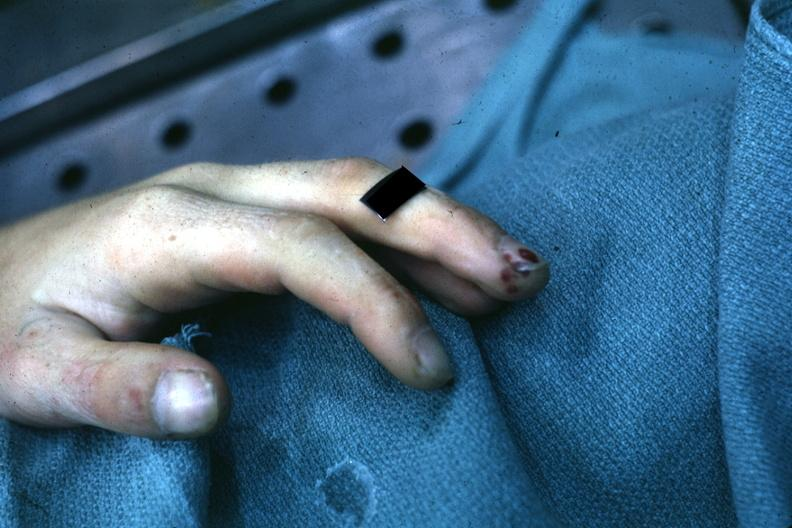s notochord present?
Answer the question using a single word or phrase. No 